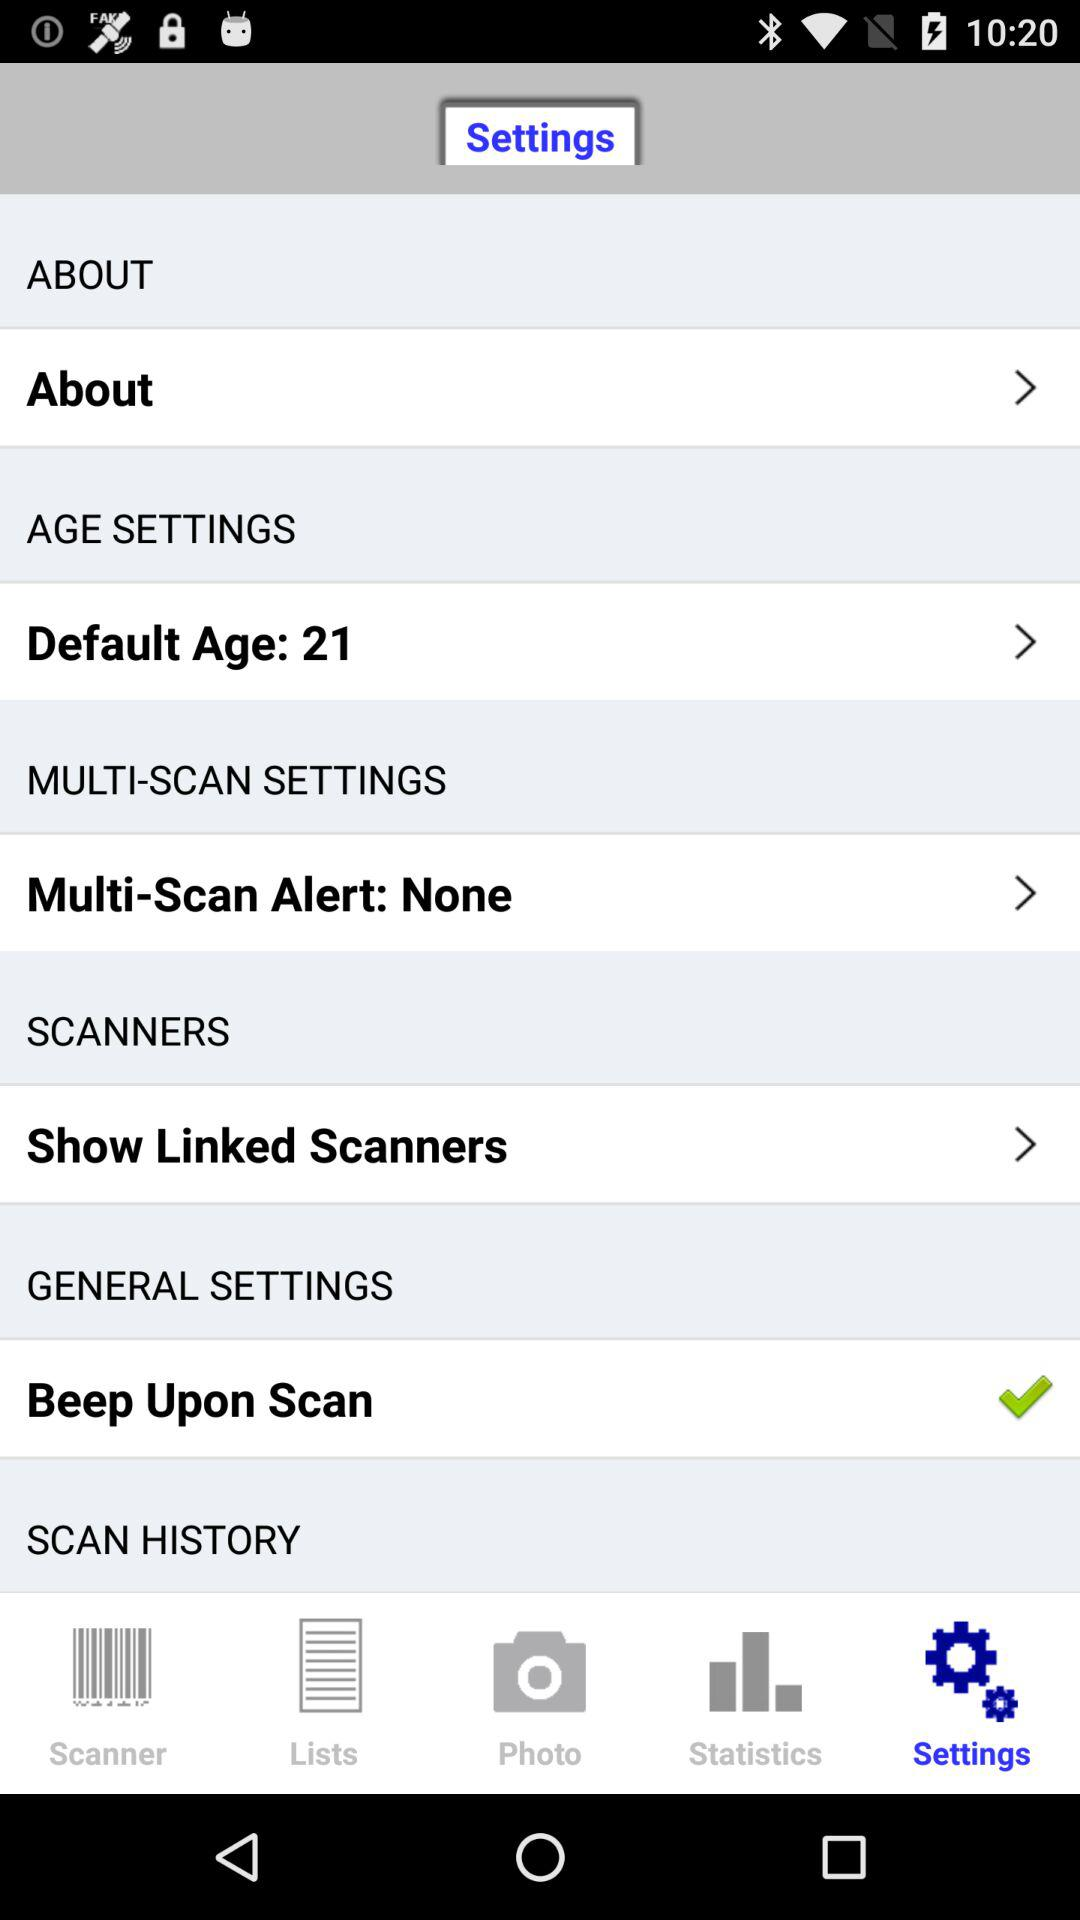What's the selected "GENERAL SETTINGS"? The selected "GENERAL SETTINGS" is "Beep Upon Scan". 